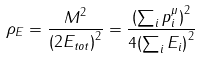<formula> <loc_0><loc_0><loc_500><loc_500>\rho _ { E } = \frac { M ^ { 2 } } { { ( 2 E _ { t o t } ) } ^ { 2 } } = \frac { { ( \sum _ { i } p _ { i } ^ { \mu } ) } ^ { 2 } } { 4 { ( \sum _ { i } E _ { i } ) } ^ { 2 } }</formula> 